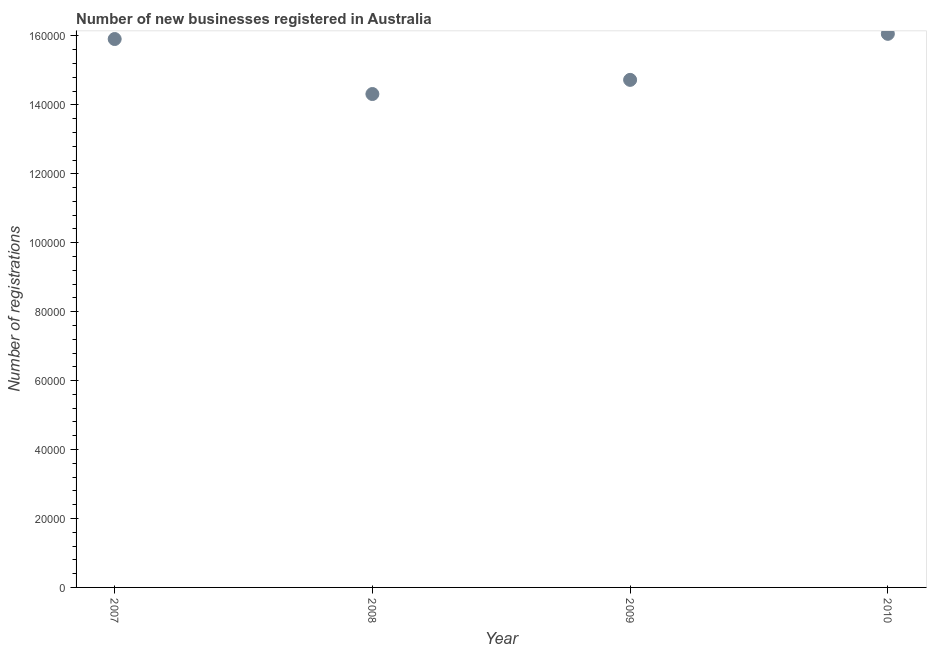What is the number of new business registrations in 2007?
Provide a short and direct response. 1.59e+05. Across all years, what is the maximum number of new business registrations?
Provide a short and direct response. 1.61e+05. Across all years, what is the minimum number of new business registrations?
Provide a short and direct response. 1.43e+05. In which year was the number of new business registrations maximum?
Ensure brevity in your answer.  2010. In which year was the number of new business registrations minimum?
Your answer should be very brief. 2008. What is the sum of the number of new business registrations?
Provide a short and direct response. 6.10e+05. What is the difference between the number of new business registrations in 2007 and 2010?
Make the answer very short. -1507. What is the average number of new business registrations per year?
Offer a terse response. 1.53e+05. What is the median number of new business registrations?
Your answer should be very brief. 1.53e+05. In how many years, is the number of new business registrations greater than 96000 ?
Ensure brevity in your answer.  4. Do a majority of the years between 2010 and 2008 (inclusive) have number of new business registrations greater than 28000 ?
Your answer should be very brief. No. What is the ratio of the number of new business registrations in 2007 to that in 2008?
Offer a terse response. 1.11. Is the number of new business registrations in 2008 less than that in 2010?
Your answer should be very brief. Yes. Is the difference between the number of new business registrations in 2008 and 2010 greater than the difference between any two years?
Make the answer very short. Yes. What is the difference between the highest and the second highest number of new business registrations?
Ensure brevity in your answer.  1507. What is the difference between the highest and the lowest number of new business registrations?
Give a very brief answer. 1.75e+04. In how many years, is the number of new business registrations greater than the average number of new business registrations taken over all years?
Offer a very short reply. 2. Does the number of new business registrations monotonically increase over the years?
Ensure brevity in your answer.  No. What is the difference between two consecutive major ticks on the Y-axis?
Ensure brevity in your answer.  2.00e+04. Does the graph contain any zero values?
Keep it short and to the point. No. Does the graph contain grids?
Provide a short and direct response. No. What is the title of the graph?
Your response must be concise. Number of new businesses registered in Australia. What is the label or title of the Y-axis?
Ensure brevity in your answer.  Number of registrations. What is the Number of registrations in 2007?
Your answer should be very brief. 1.59e+05. What is the Number of registrations in 2008?
Your answer should be compact. 1.43e+05. What is the Number of registrations in 2009?
Ensure brevity in your answer.  1.47e+05. What is the Number of registrations in 2010?
Your answer should be compact. 1.61e+05. What is the difference between the Number of registrations in 2007 and 2008?
Make the answer very short. 1.60e+04. What is the difference between the Number of registrations in 2007 and 2009?
Make the answer very short. 1.18e+04. What is the difference between the Number of registrations in 2007 and 2010?
Your response must be concise. -1507. What is the difference between the Number of registrations in 2008 and 2009?
Give a very brief answer. -4105. What is the difference between the Number of registrations in 2008 and 2010?
Your response must be concise. -1.75e+04. What is the difference between the Number of registrations in 2009 and 2010?
Your response must be concise. -1.34e+04. What is the ratio of the Number of registrations in 2007 to that in 2008?
Your answer should be compact. 1.11. What is the ratio of the Number of registrations in 2007 to that in 2009?
Your answer should be compact. 1.08. What is the ratio of the Number of registrations in 2008 to that in 2010?
Offer a very short reply. 0.89. What is the ratio of the Number of registrations in 2009 to that in 2010?
Provide a succinct answer. 0.92. 